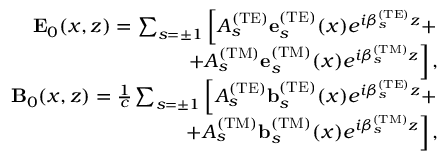<formula> <loc_0><loc_0><loc_500><loc_500>\begin{array} { r l r } & { { E } _ { 0 } ( x , z ) = \sum _ { s = \pm 1 } \left [ A _ { s } ^ { ( T E ) } { e } _ { s } ^ { ( T E ) } ( x ) e ^ { i \beta _ { s } ^ { ( T E ) } z } + } \\ & { + A _ { s } ^ { ( T M ) } { e } _ { s } ^ { ( T M ) } ( x ) e ^ { i \beta _ { s } ^ { ( T M ) } z } \right ] , } \\ & { { B } _ { 0 } ( x , z ) = \frac { 1 } { c } \sum _ { s = \pm 1 } \left [ A _ { s } ^ { ( T E ) } { b } _ { s } ^ { ( T E ) } ( x ) e ^ { i \beta _ { s } ^ { ( T E ) } z } + } \\ & { + A _ { s } ^ { ( T M ) } { b } _ { s } ^ { ( T M ) } ( x ) e ^ { i \beta _ { s } ^ { ( T M ) } z } \right ] , } \end{array}</formula> 